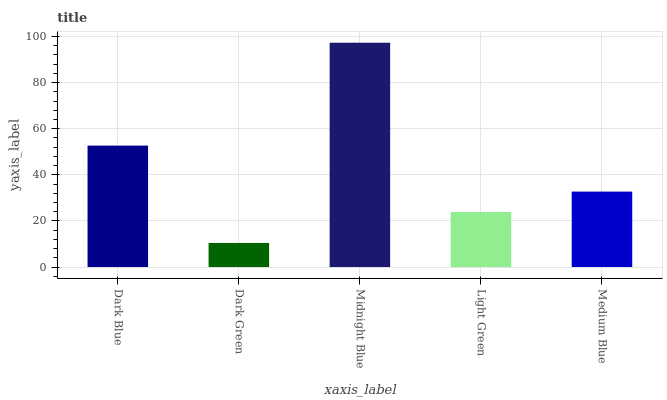Is Dark Green the minimum?
Answer yes or no. Yes. Is Midnight Blue the maximum?
Answer yes or no. Yes. Is Midnight Blue the minimum?
Answer yes or no. No. Is Dark Green the maximum?
Answer yes or no. No. Is Midnight Blue greater than Dark Green?
Answer yes or no. Yes. Is Dark Green less than Midnight Blue?
Answer yes or no. Yes. Is Dark Green greater than Midnight Blue?
Answer yes or no. No. Is Midnight Blue less than Dark Green?
Answer yes or no. No. Is Medium Blue the high median?
Answer yes or no. Yes. Is Medium Blue the low median?
Answer yes or no. Yes. Is Light Green the high median?
Answer yes or no. No. Is Dark Green the low median?
Answer yes or no. No. 